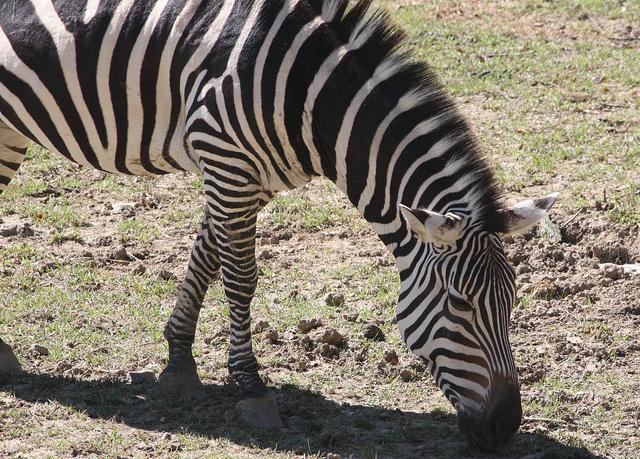What kind of animal is this?
Short answer required. Zebra. Does the animal have pointed ears?
Be succinct. Yes. Is the ground muddy or dry?
Answer briefly. Dry. How many zebras are here?
Give a very brief answer. 1. 